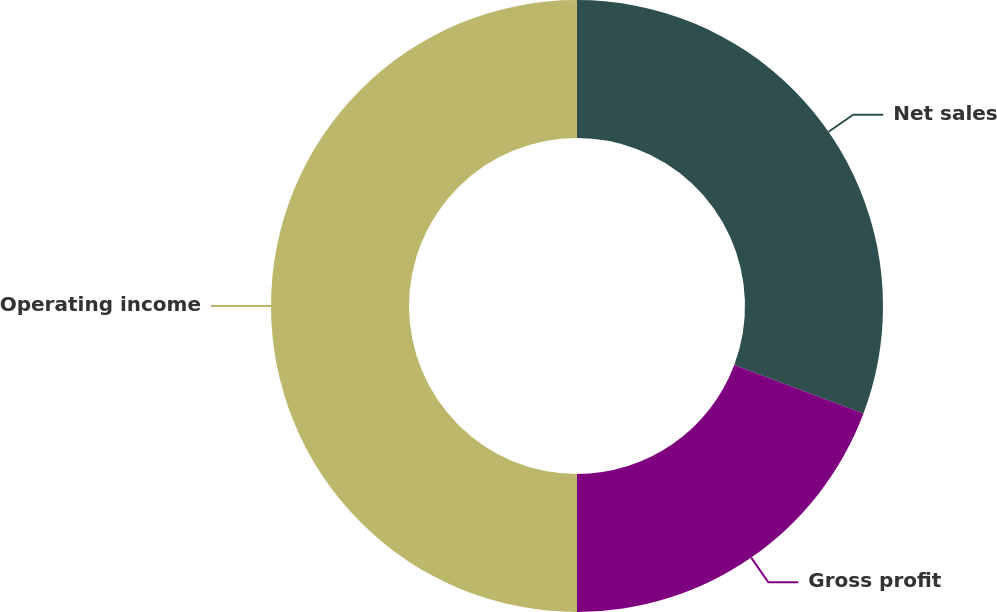Convert chart. <chart><loc_0><loc_0><loc_500><loc_500><pie_chart><fcel>Net sales<fcel>Gross profit<fcel>Operating income<nl><fcel>30.72%<fcel>19.28%<fcel>50.0%<nl></chart> 